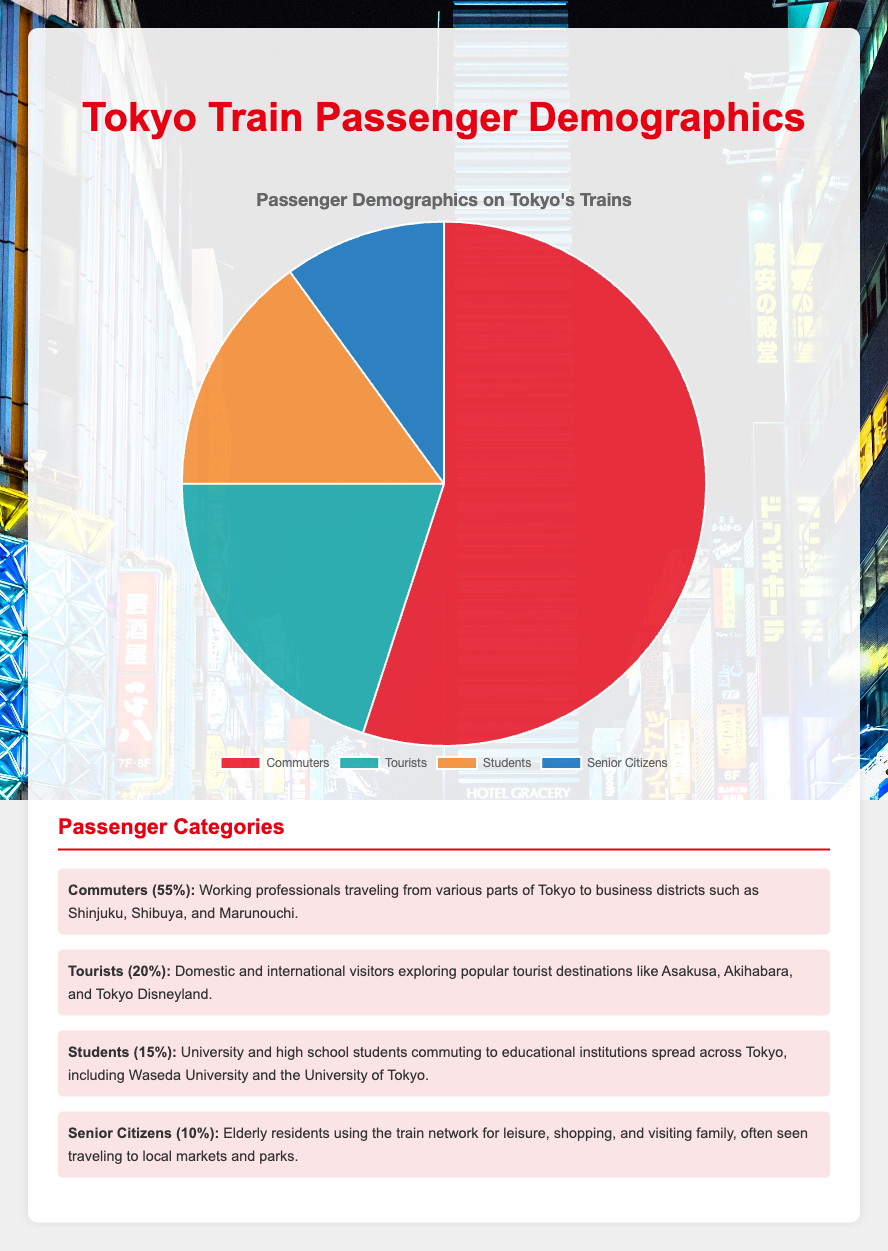What percentage of Tokyo train passengers are either students or senior citizens? First, identify the percentages for students (15%) and senior citizens (10%). Add these two percentages together to get the combined percentage of these two groups. 15% + 10% = 25%.
Answer: 25% Which group has the smallest percentage of passengers? By examining the pie chart, it is evident that senior citizens have the smallest percentage at 10%.
Answer: Senior Citizens How much larger is the commuter group compared to the tourist group? Identify the percentages for commuters (55%) and tourists (20%). Subtract the tourist percentage from the commuter percentage: 55% - 20% = 35%.
Answer: 35% What is the combined percentage of commuters and tourists? To find the combined percentage, add the percentages for commuters (55%) and tourists (20%). 55% + 20% = 75%.
Answer: 75% Which group is represented by the blue color slice in the pie chart? According to the data provided, the blue color slice represents senior citizens, who make up 10% of the chart.
Answer: Senior Citizens How do tourists and students together compare to commuters in terms of percentage? Add the percentages of tourists (20%) and students (15%) first: 20% + 15% = 35%. Compare this total to the commuters' percentage of 55%. 35% < 55%, so they are less than commuters.
Answer: Less Which group has a larger percentage: students or senior citizens? By how much? Compare the percentages of the two groups: students (15%) and senior citizens (10%). Calculate the difference: 15% - 10% = 5%.
Answer: Students, by 5% What percentage of passengers can be categorized as non-commuters? Identify the percentage for commuters (55%) and subtract it from 100%: 100% - 55% = 45%.
Answer: 45% What is the difference in percentage between the largest group and the smallest group? Determine that the largest group is commuters (55%) and the smallest group is senior citizens (10%). Subtract the smaller percentage from the larger: 55% - 10% = 45%.
Answer: 45% Which category has a red color in the pie chart? According to the given color-coding, the red color slice represents commuters, who comprise 55% of the pie chart.
Answer: Commuters 